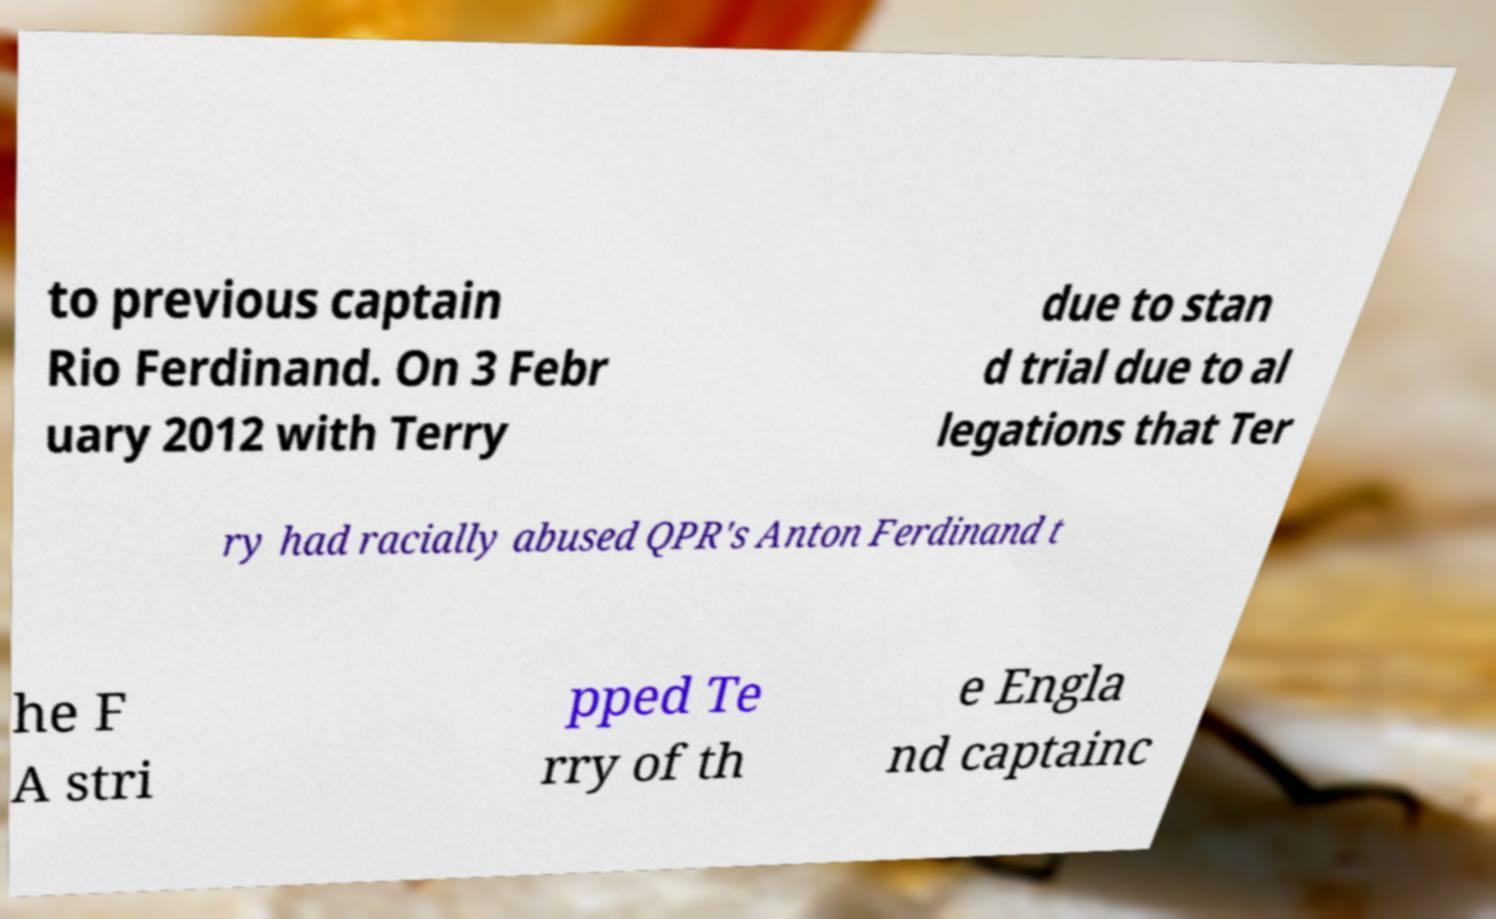There's text embedded in this image that I need extracted. Can you transcribe it verbatim? to previous captain Rio Ferdinand. On 3 Febr uary 2012 with Terry due to stan d trial due to al legations that Ter ry had racially abused QPR's Anton Ferdinand t he F A stri pped Te rry of th e Engla nd captainc 